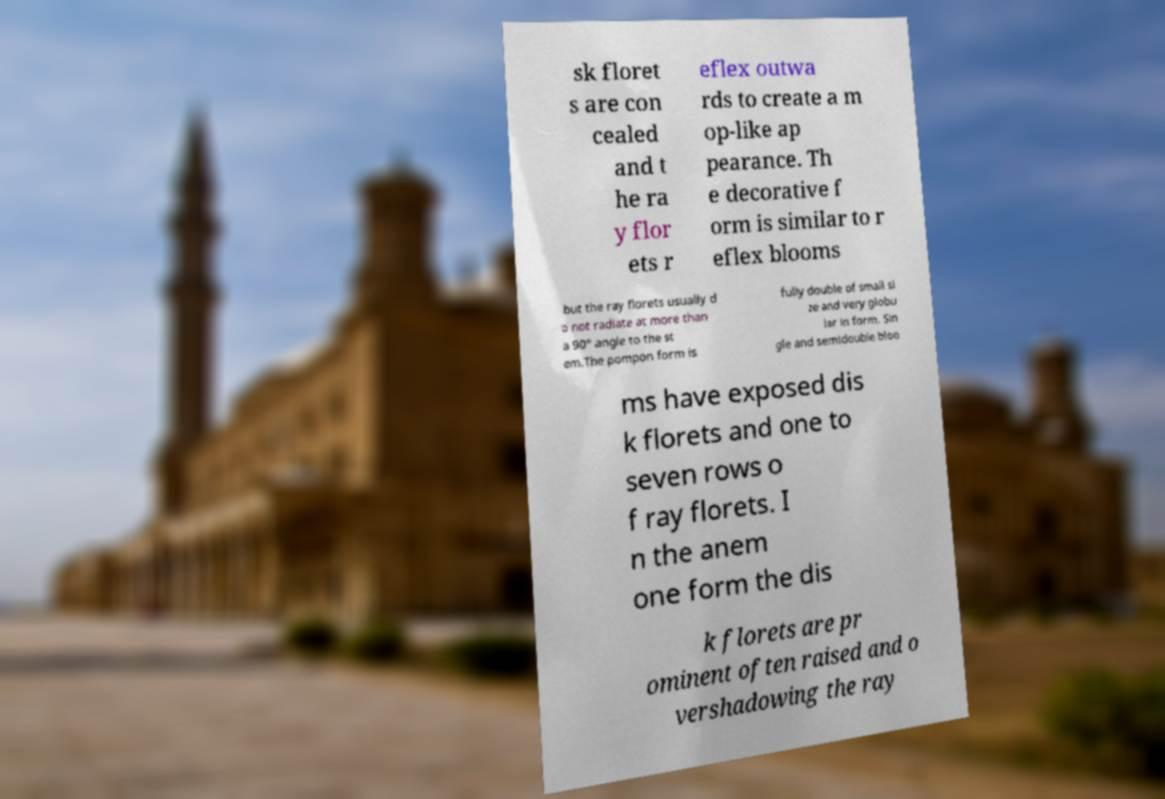What messages or text are displayed in this image? I need them in a readable, typed format. sk floret s are con cealed and t he ra y flor ets r eflex outwa rds to create a m op-like ap pearance. Th e decorative f orm is similar to r eflex blooms but the ray florets usually d o not radiate at more than a 90° angle to the st em.The pompon form is fully double of small si ze and very globu lar in form. Sin gle and semidouble bloo ms have exposed dis k florets and one to seven rows o f ray florets. I n the anem one form the dis k florets are pr ominent often raised and o vershadowing the ray 